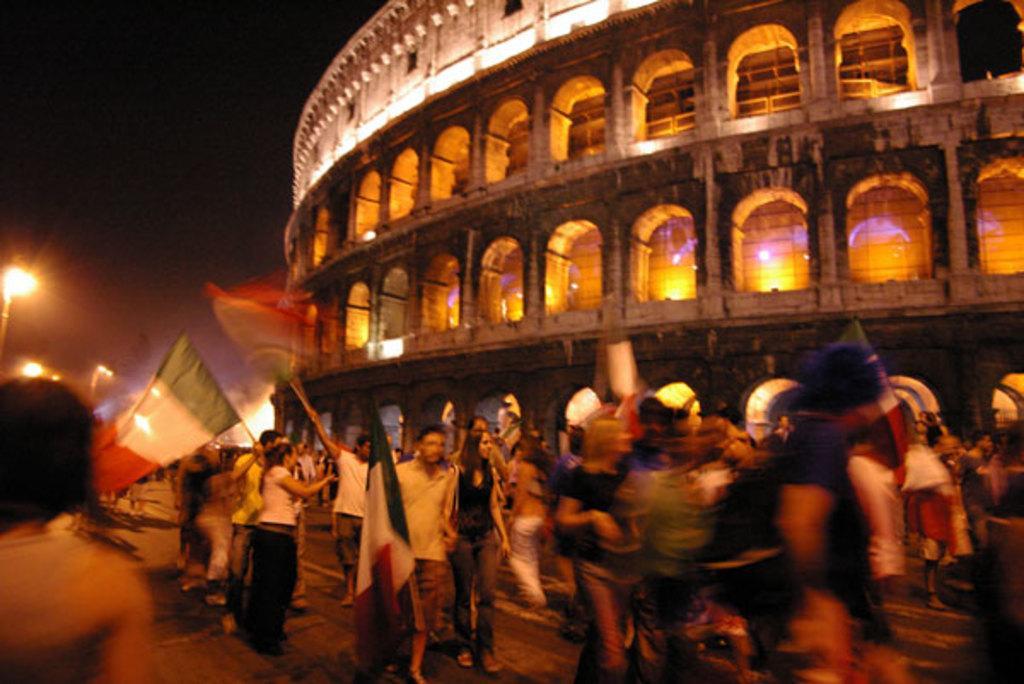How would you summarize this image in a sentence or two? In this picture I can see group of people standing and holding flags, there is a building and there are lights. 